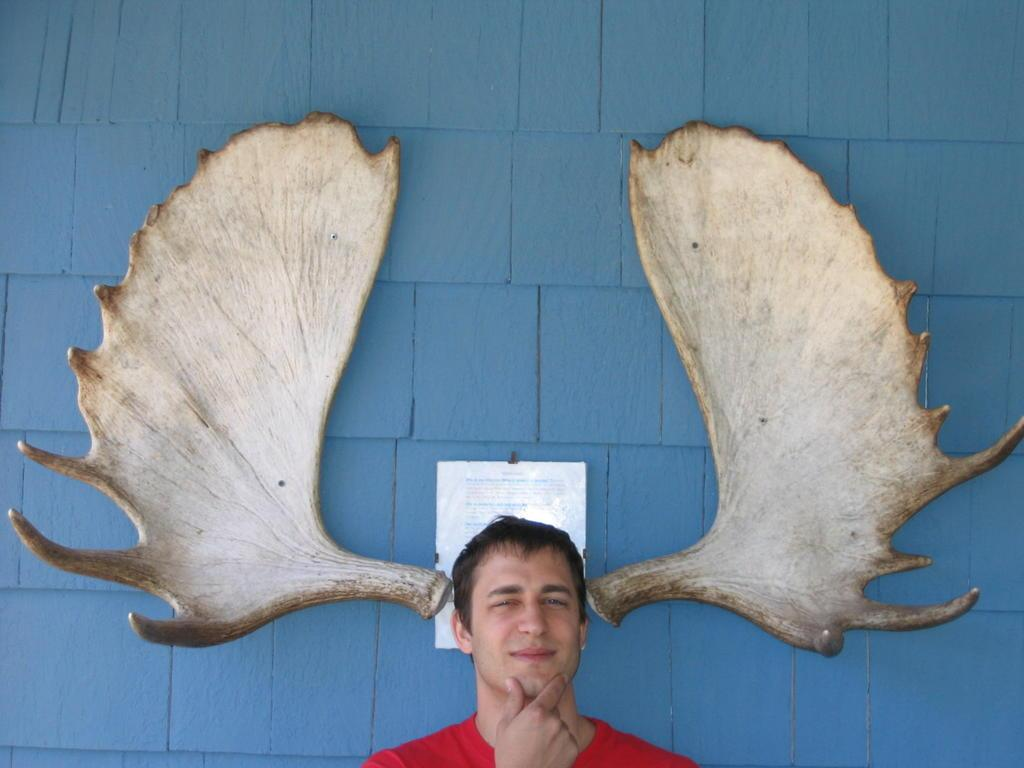What is present in the image? There is a person in the image. What can be seen in the background of the image? There is a wall with a poster in the background of the image. Can you describe any objects visible in the image? There are some objects visible in the image. How many bikes are being sorted by the person in the image? There is no mention of bikes or sorting in the image. The image only shows a person, a wall with a poster, and some objects. 